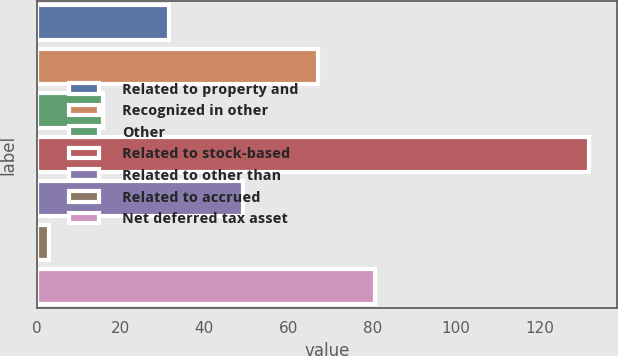<chart> <loc_0><loc_0><loc_500><loc_500><bar_chart><fcel>Related to property and<fcel>Recognized in other<fcel>Other<fcel>Related to stock-based<fcel>Related to other than<fcel>Related to accrued<fcel>Net deferred tax asset<nl><fcel>31.5<fcel>67.1<fcel>15.79<fcel>131.8<fcel>49.3<fcel>2.9<fcel>80.6<nl></chart> 